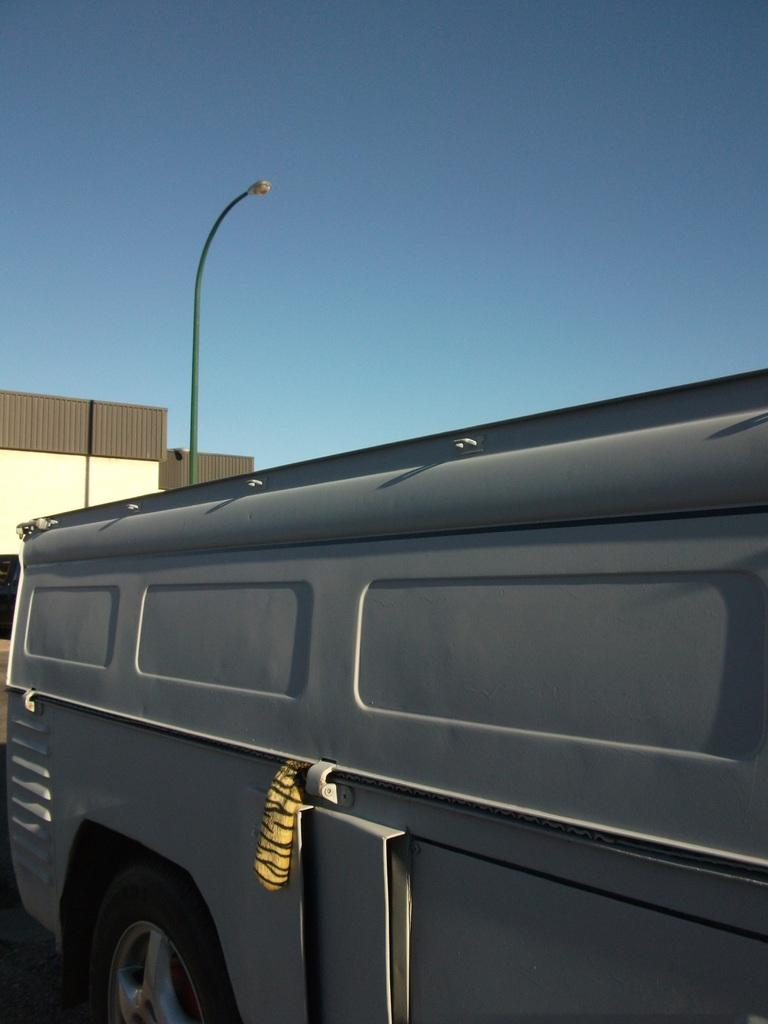What is the main subject in the picture? There is a vehicle in the picture. What else can be seen in the picture besides the vehicle? There is a building and a pole with a light in the picture. What is visible in the background of the picture? The sky is visible in the background of the picture. How many ants can be seen crawling on the vehicle in the picture? There are no ants visible in the picture; the focus is on the vehicle, building, pole with a light, and the sky. 